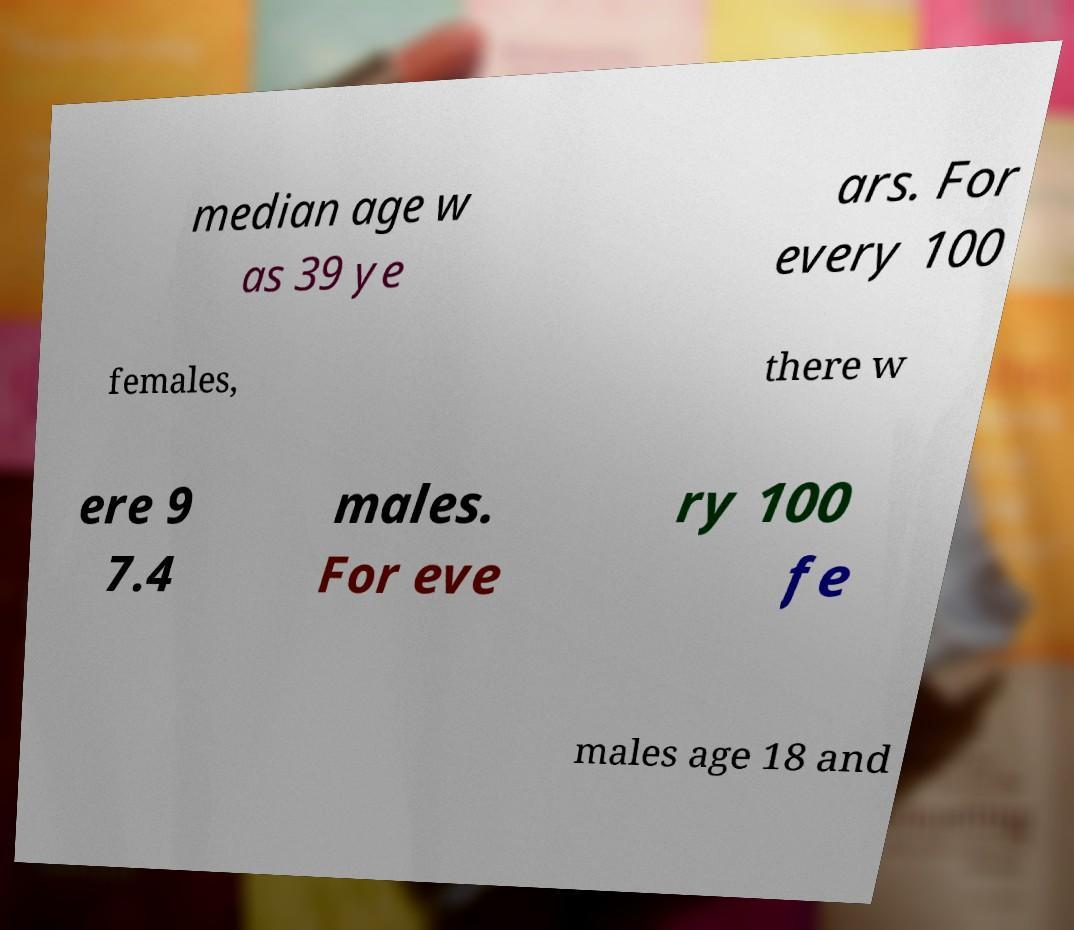What messages or text are displayed in this image? I need them in a readable, typed format. median age w as 39 ye ars. For every 100 females, there w ere 9 7.4 males. For eve ry 100 fe males age 18 and 